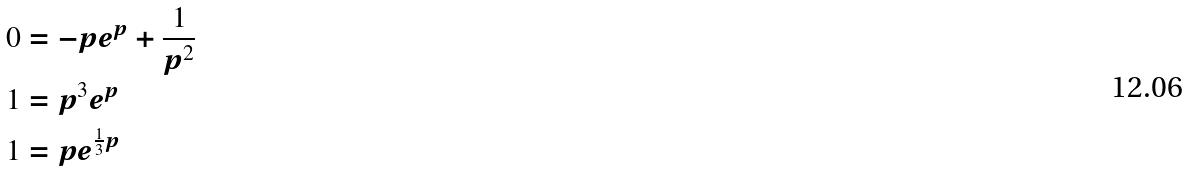Convert formula to latex. <formula><loc_0><loc_0><loc_500><loc_500>0 & = - p e ^ { p } + \frac { 1 } { p ^ { 2 } } \\ 1 & = p ^ { 3 } e ^ { p } \\ 1 & = p e ^ { \frac { 1 } { 3 } p }</formula> 